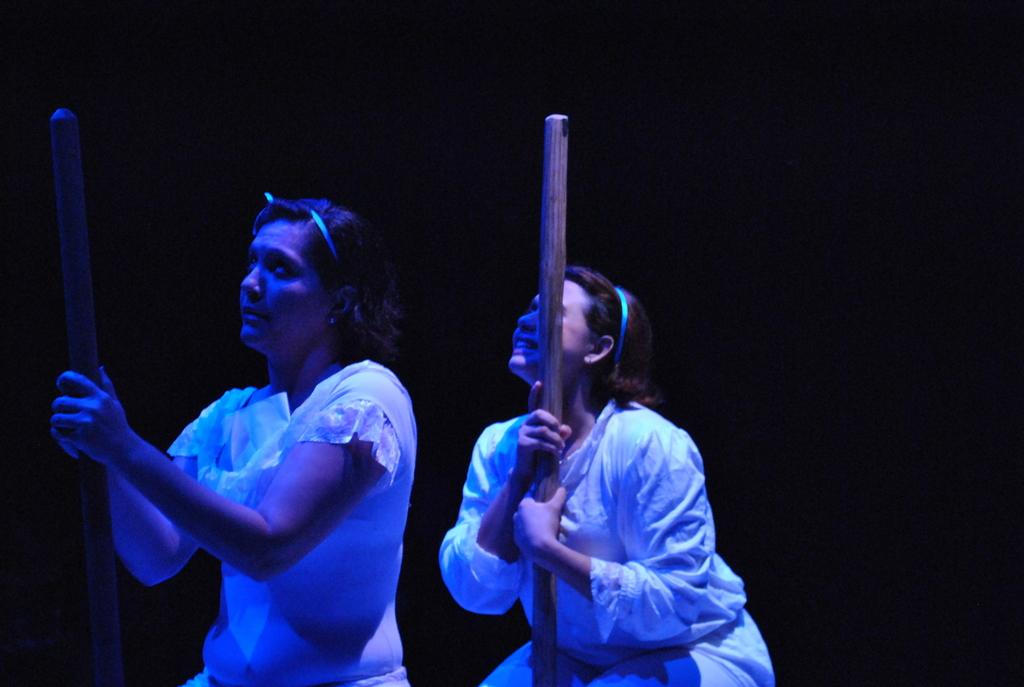How many people are in the image? There are two girls in the image. What are the girls wearing? The girls are wearing white dresses. What are the girls holding in their hands? The girls are holding sticks. Are there any beds visible in the image? No, there are no beds present in the image. Can you see any steam coming from the sticks the girls are holding? No, there is no steam visible in the image. 